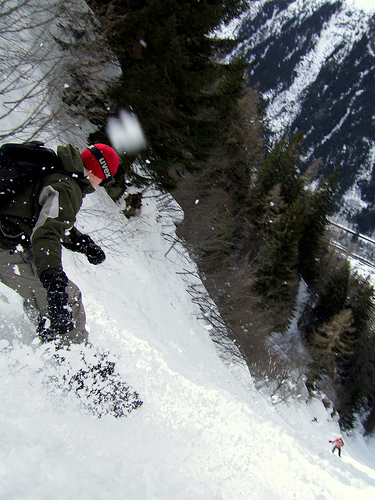<image>
Can you confirm if the man is next to the boy? No. The man is not positioned next to the boy. They are located in different areas of the scene. 